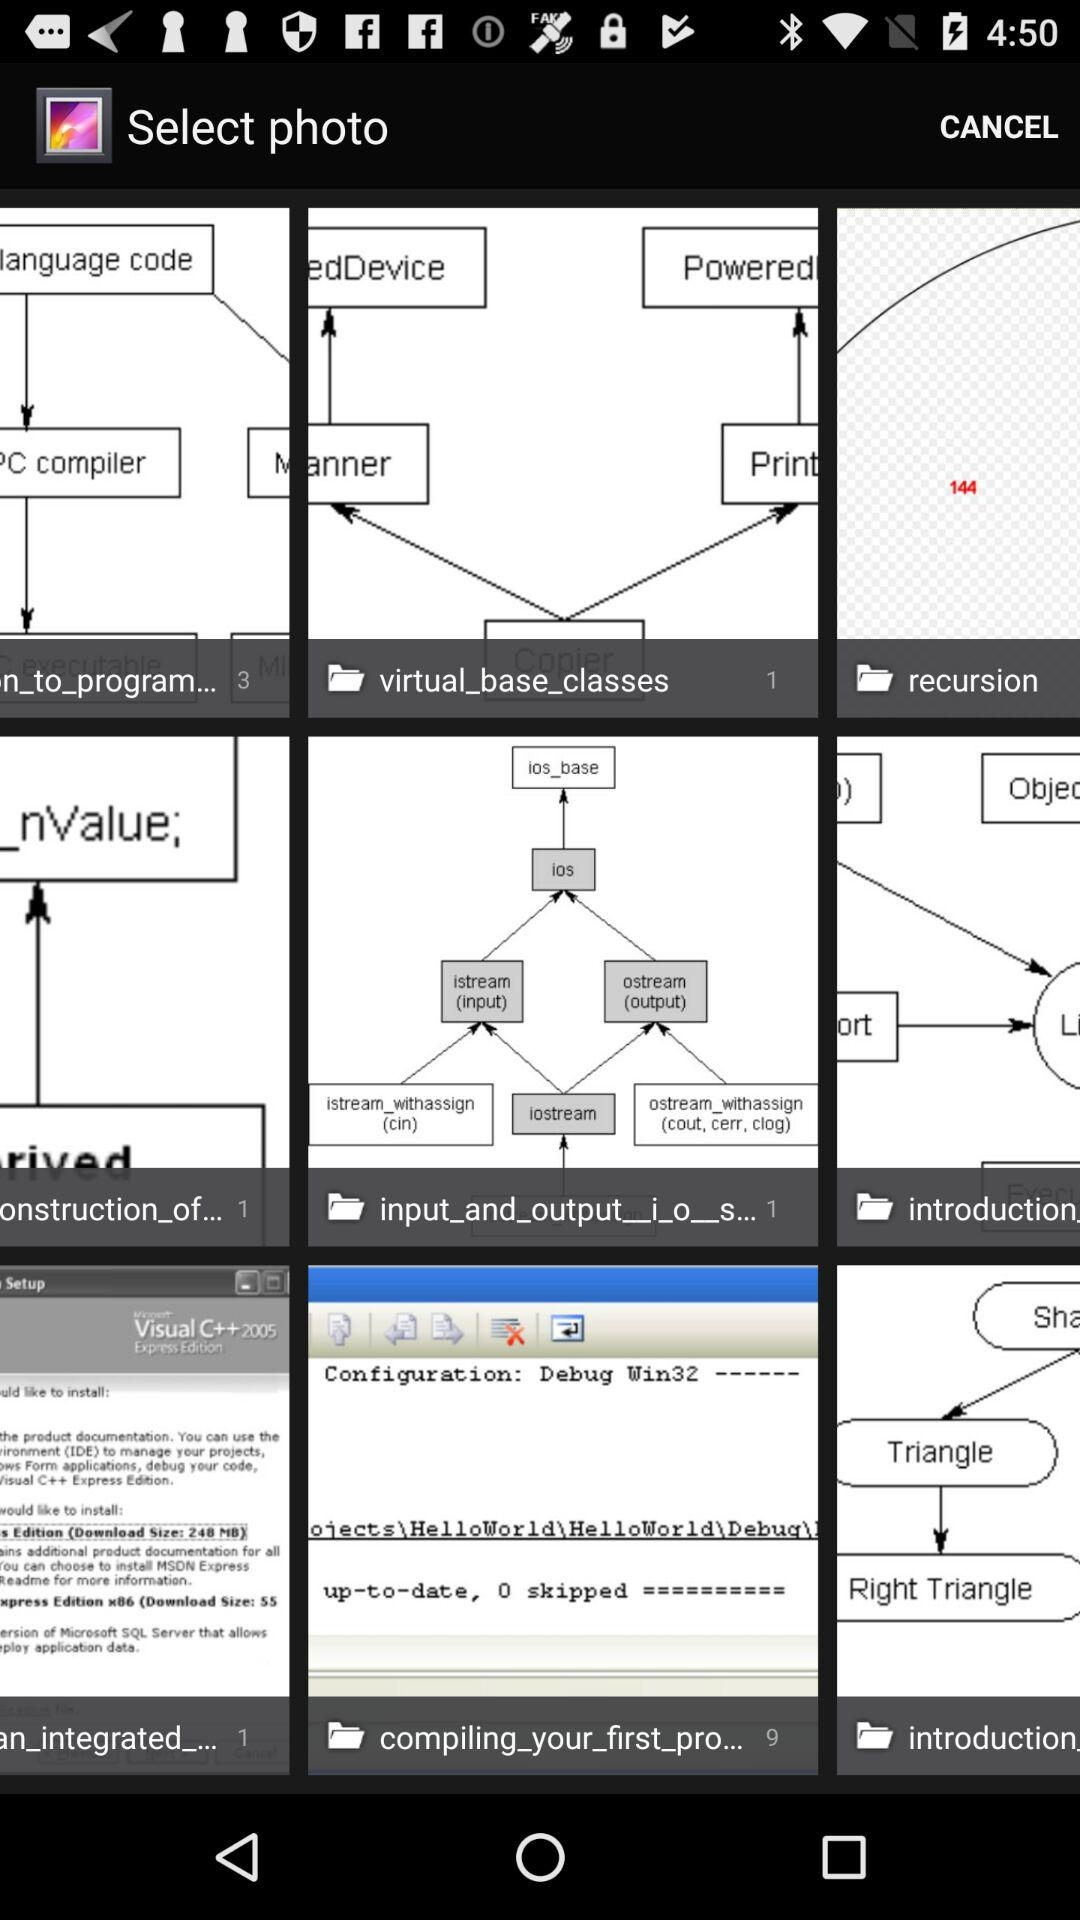Which folder has 9 images? The folder is "compiling_your_first_pro...". 